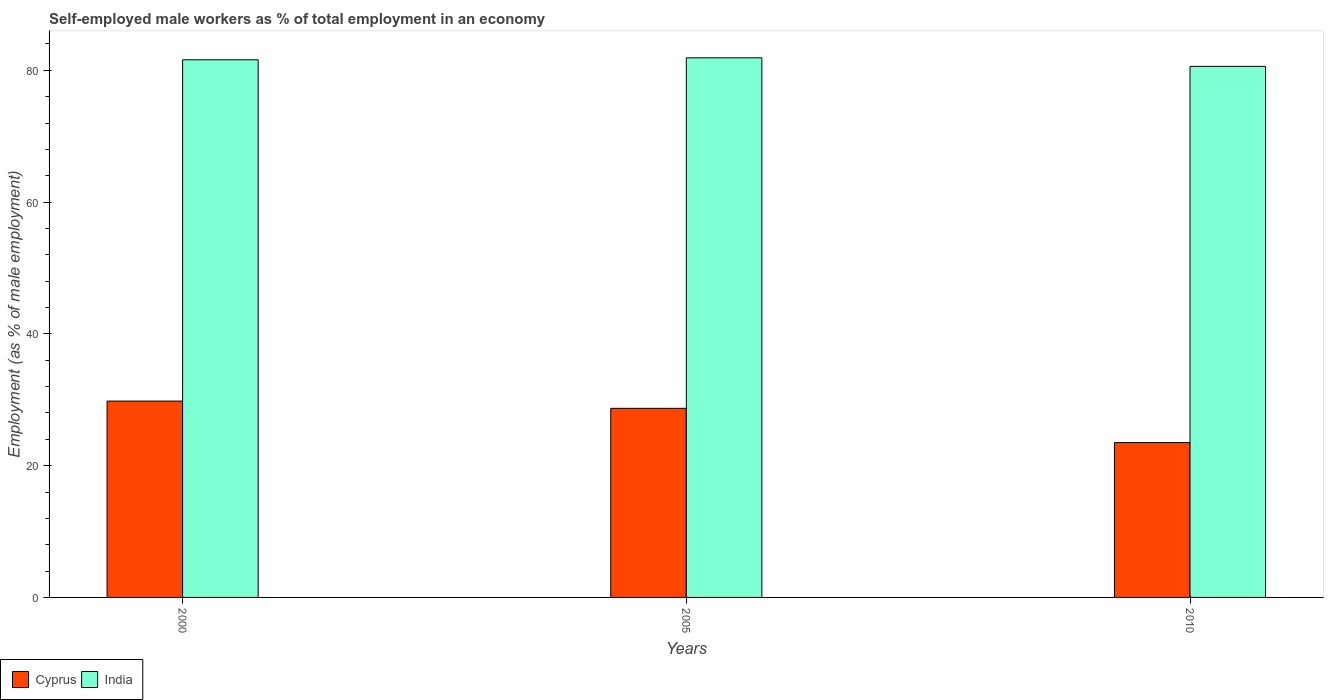How many different coloured bars are there?
Keep it short and to the point. 2. How many groups of bars are there?
Ensure brevity in your answer.  3. Are the number of bars per tick equal to the number of legend labels?
Your response must be concise. Yes. How many bars are there on the 2nd tick from the right?
Offer a very short reply. 2. In how many cases, is the number of bars for a given year not equal to the number of legend labels?
Offer a terse response. 0. What is the percentage of self-employed male workers in India in 2000?
Offer a very short reply. 81.6. Across all years, what is the maximum percentage of self-employed male workers in India?
Provide a succinct answer. 81.9. Across all years, what is the minimum percentage of self-employed male workers in India?
Offer a terse response. 80.6. In which year was the percentage of self-employed male workers in Cyprus maximum?
Your answer should be very brief. 2000. In which year was the percentage of self-employed male workers in India minimum?
Give a very brief answer. 2010. What is the total percentage of self-employed male workers in Cyprus in the graph?
Provide a succinct answer. 82. What is the difference between the percentage of self-employed male workers in India in 2000 and that in 2005?
Offer a terse response. -0.3. What is the difference between the percentage of self-employed male workers in India in 2000 and the percentage of self-employed male workers in Cyprus in 2010?
Offer a very short reply. 58.1. What is the average percentage of self-employed male workers in Cyprus per year?
Offer a very short reply. 27.33. In the year 2000, what is the difference between the percentage of self-employed male workers in India and percentage of self-employed male workers in Cyprus?
Your answer should be compact. 51.8. What is the ratio of the percentage of self-employed male workers in Cyprus in 2005 to that in 2010?
Your response must be concise. 1.22. Is the percentage of self-employed male workers in India in 2005 less than that in 2010?
Your answer should be compact. No. What is the difference between the highest and the second highest percentage of self-employed male workers in Cyprus?
Give a very brief answer. 1.1. What is the difference between the highest and the lowest percentage of self-employed male workers in India?
Give a very brief answer. 1.3. Is the sum of the percentage of self-employed male workers in Cyprus in 2005 and 2010 greater than the maximum percentage of self-employed male workers in India across all years?
Your answer should be very brief. No. What does the 2nd bar from the left in 2000 represents?
Keep it short and to the point. India. What does the 1st bar from the right in 2000 represents?
Your answer should be very brief. India. Are the values on the major ticks of Y-axis written in scientific E-notation?
Provide a short and direct response. No. What is the title of the graph?
Provide a short and direct response. Self-employed male workers as % of total employment in an economy. Does "El Salvador" appear as one of the legend labels in the graph?
Provide a short and direct response. No. What is the label or title of the X-axis?
Offer a terse response. Years. What is the label or title of the Y-axis?
Offer a very short reply. Employment (as % of male employment). What is the Employment (as % of male employment) in Cyprus in 2000?
Provide a short and direct response. 29.8. What is the Employment (as % of male employment) of India in 2000?
Offer a terse response. 81.6. What is the Employment (as % of male employment) in Cyprus in 2005?
Give a very brief answer. 28.7. What is the Employment (as % of male employment) in India in 2005?
Offer a very short reply. 81.9. What is the Employment (as % of male employment) in Cyprus in 2010?
Offer a terse response. 23.5. What is the Employment (as % of male employment) of India in 2010?
Your response must be concise. 80.6. Across all years, what is the maximum Employment (as % of male employment) in Cyprus?
Keep it short and to the point. 29.8. Across all years, what is the maximum Employment (as % of male employment) in India?
Your answer should be compact. 81.9. Across all years, what is the minimum Employment (as % of male employment) in India?
Your answer should be compact. 80.6. What is the total Employment (as % of male employment) in India in the graph?
Offer a very short reply. 244.1. What is the difference between the Employment (as % of male employment) of India in 2000 and that in 2005?
Provide a short and direct response. -0.3. What is the difference between the Employment (as % of male employment) of Cyprus in 2000 and that in 2010?
Your answer should be compact. 6.3. What is the difference between the Employment (as % of male employment) in India in 2000 and that in 2010?
Make the answer very short. 1. What is the difference between the Employment (as % of male employment) in Cyprus in 2000 and the Employment (as % of male employment) in India in 2005?
Offer a very short reply. -52.1. What is the difference between the Employment (as % of male employment) of Cyprus in 2000 and the Employment (as % of male employment) of India in 2010?
Offer a very short reply. -50.8. What is the difference between the Employment (as % of male employment) in Cyprus in 2005 and the Employment (as % of male employment) in India in 2010?
Offer a terse response. -51.9. What is the average Employment (as % of male employment) in Cyprus per year?
Make the answer very short. 27.33. What is the average Employment (as % of male employment) in India per year?
Offer a terse response. 81.37. In the year 2000, what is the difference between the Employment (as % of male employment) of Cyprus and Employment (as % of male employment) of India?
Your response must be concise. -51.8. In the year 2005, what is the difference between the Employment (as % of male employment) in Cyprus and Employment (as % of male employment) in India?
Make the answer very short. -53.2. In the year 2010, what is the difference between the Employment (as % of male employment) of Cyprus and Employment (as % of male employment) of India?
Provide a succinct answer. -57.1. What is the ratio of the Employment (as % of male employment) in Cyprus in 2000 to that in 2005?
Provide a succinct answer. 1.04. What is the ratio of the Employment (as % of male employment) of Cyprus in 2000 to that in 2010?
Your answer should be very brief. 1.27. What is the ratio of the Employment (as % of male employment) of India in 2000 to that in 2010?
Offer a very short reply. 1.01. What is the ratio of the Employment (as % of male employment) in Cyprus in 2005 to that in 2010?
Offer a very short reply. 1.22. What is the ratio of the Employment (as % of male employment) of India in 2005 to that in 2010?
Keep it short and to the point. 1.02. What is the difference between the highest and the second highest Employment (as % of male employment) in Cyprus?
Provide a succinct answer. 1.1. 